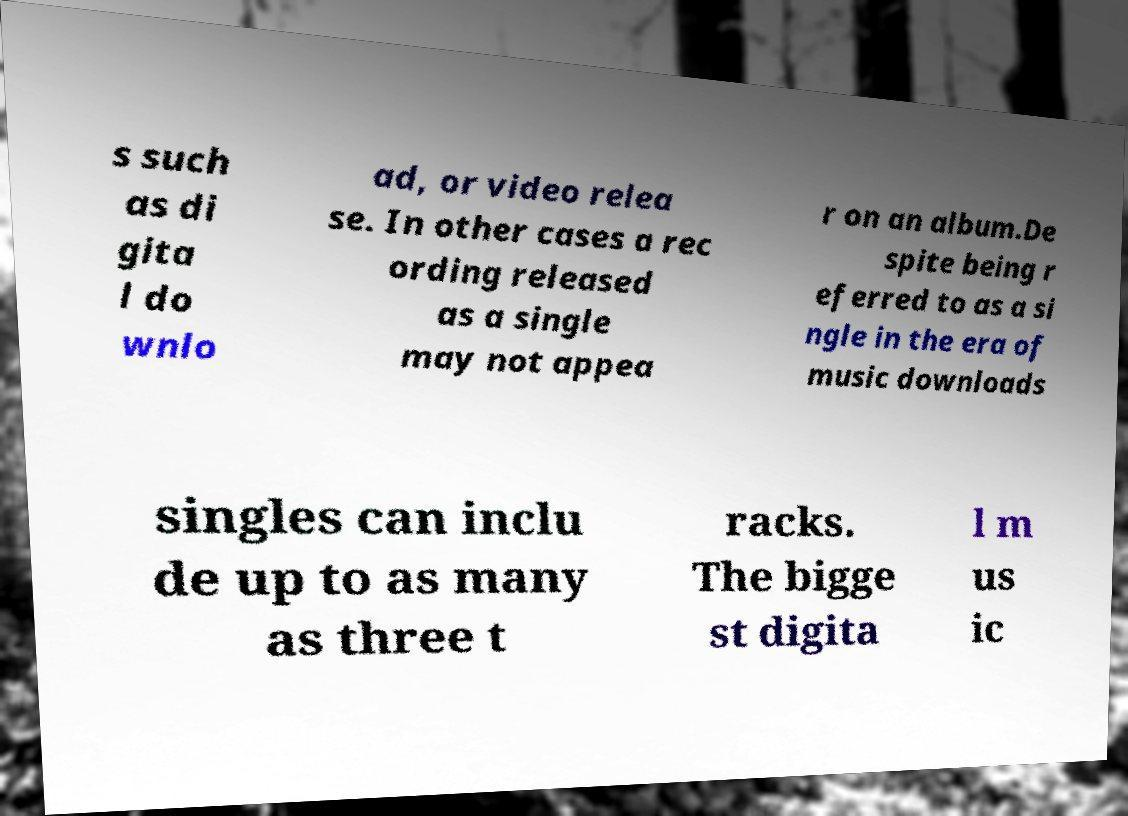There's text embedded in this image that I need extracted. Can you transcribe it verbatim? s such as di gita l do wnlo ad, or video relea se. In other cases a rec ording released as a single may not appea r on an album.De spite being r eferred to as a si ngle in the era of music downloads singles can inclu de up to as many as three t racks. The bigge st digita l m us ic 